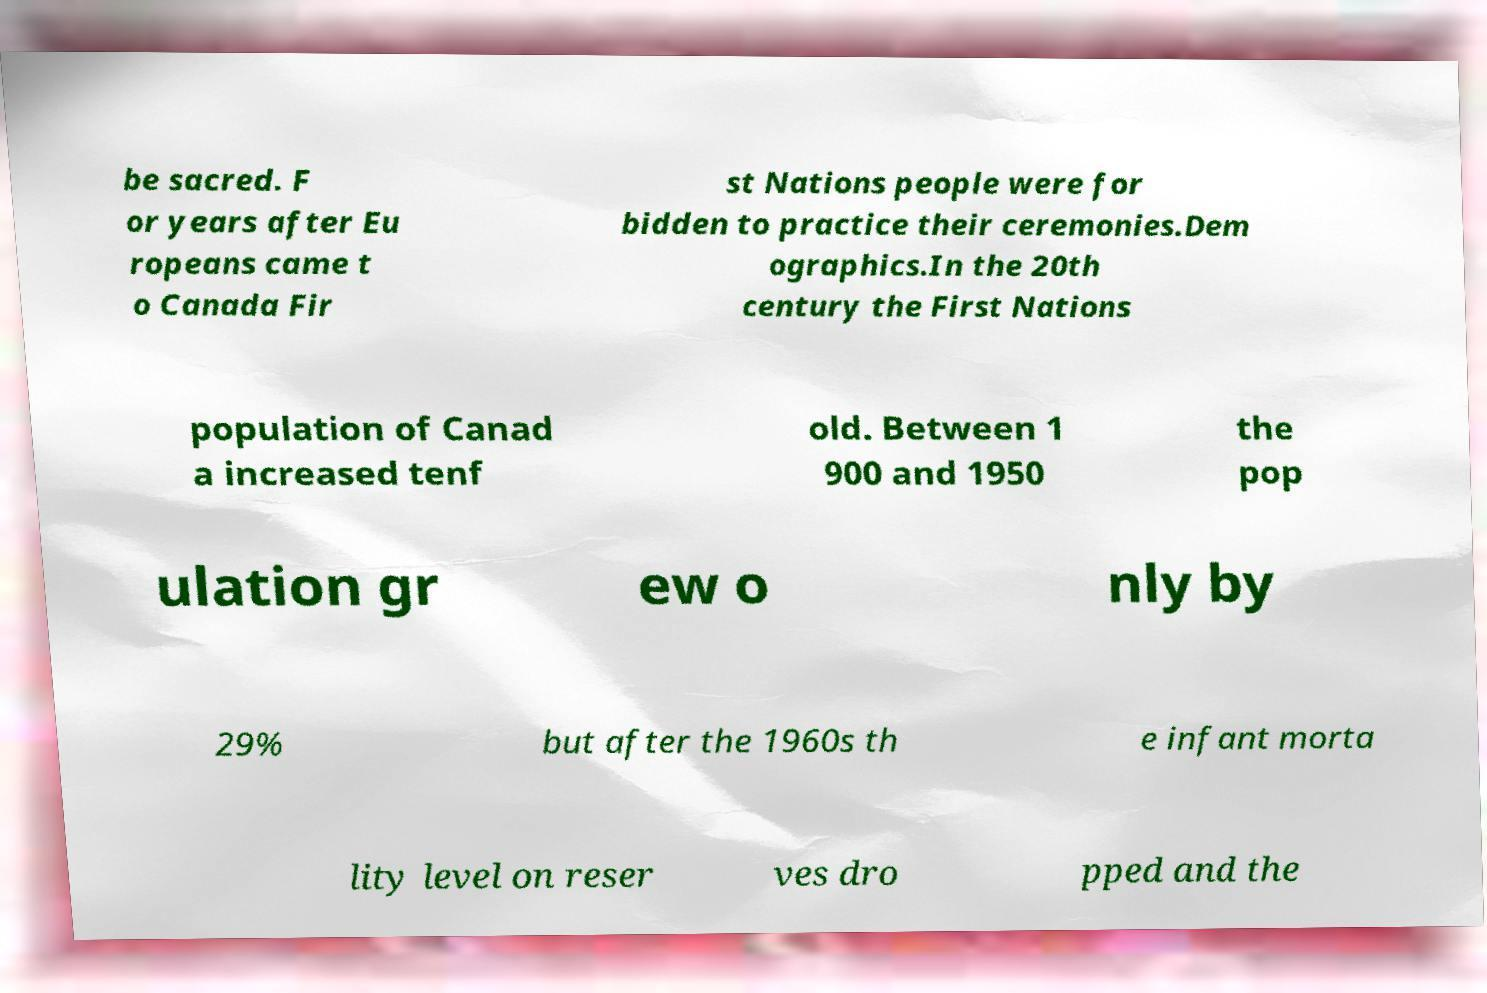Please read and relay the text visible in this image. What does it say? be sacred. F or years after Eu ropeans came t o Canada Fir st Nations people were for bidden to practice their ceremonies.Dem ographics.In the 20th century the First Nations population of Canad a increased tenf old. Between 1 900 and 1950 the pop ulation gr ew o nly by 29% but after the 1960s th e infant morta lity level on reser ves dro pped and the 